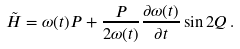<formula> <loc_0><loc_0><loc_500><loc_500>\tilde { H } = \omega ( t ) P + \frac { P } { 2 \omega ( t ) } \frac { \partial \omega ( t ) } { \partial t } \sin 2 Q \, .</formula> 